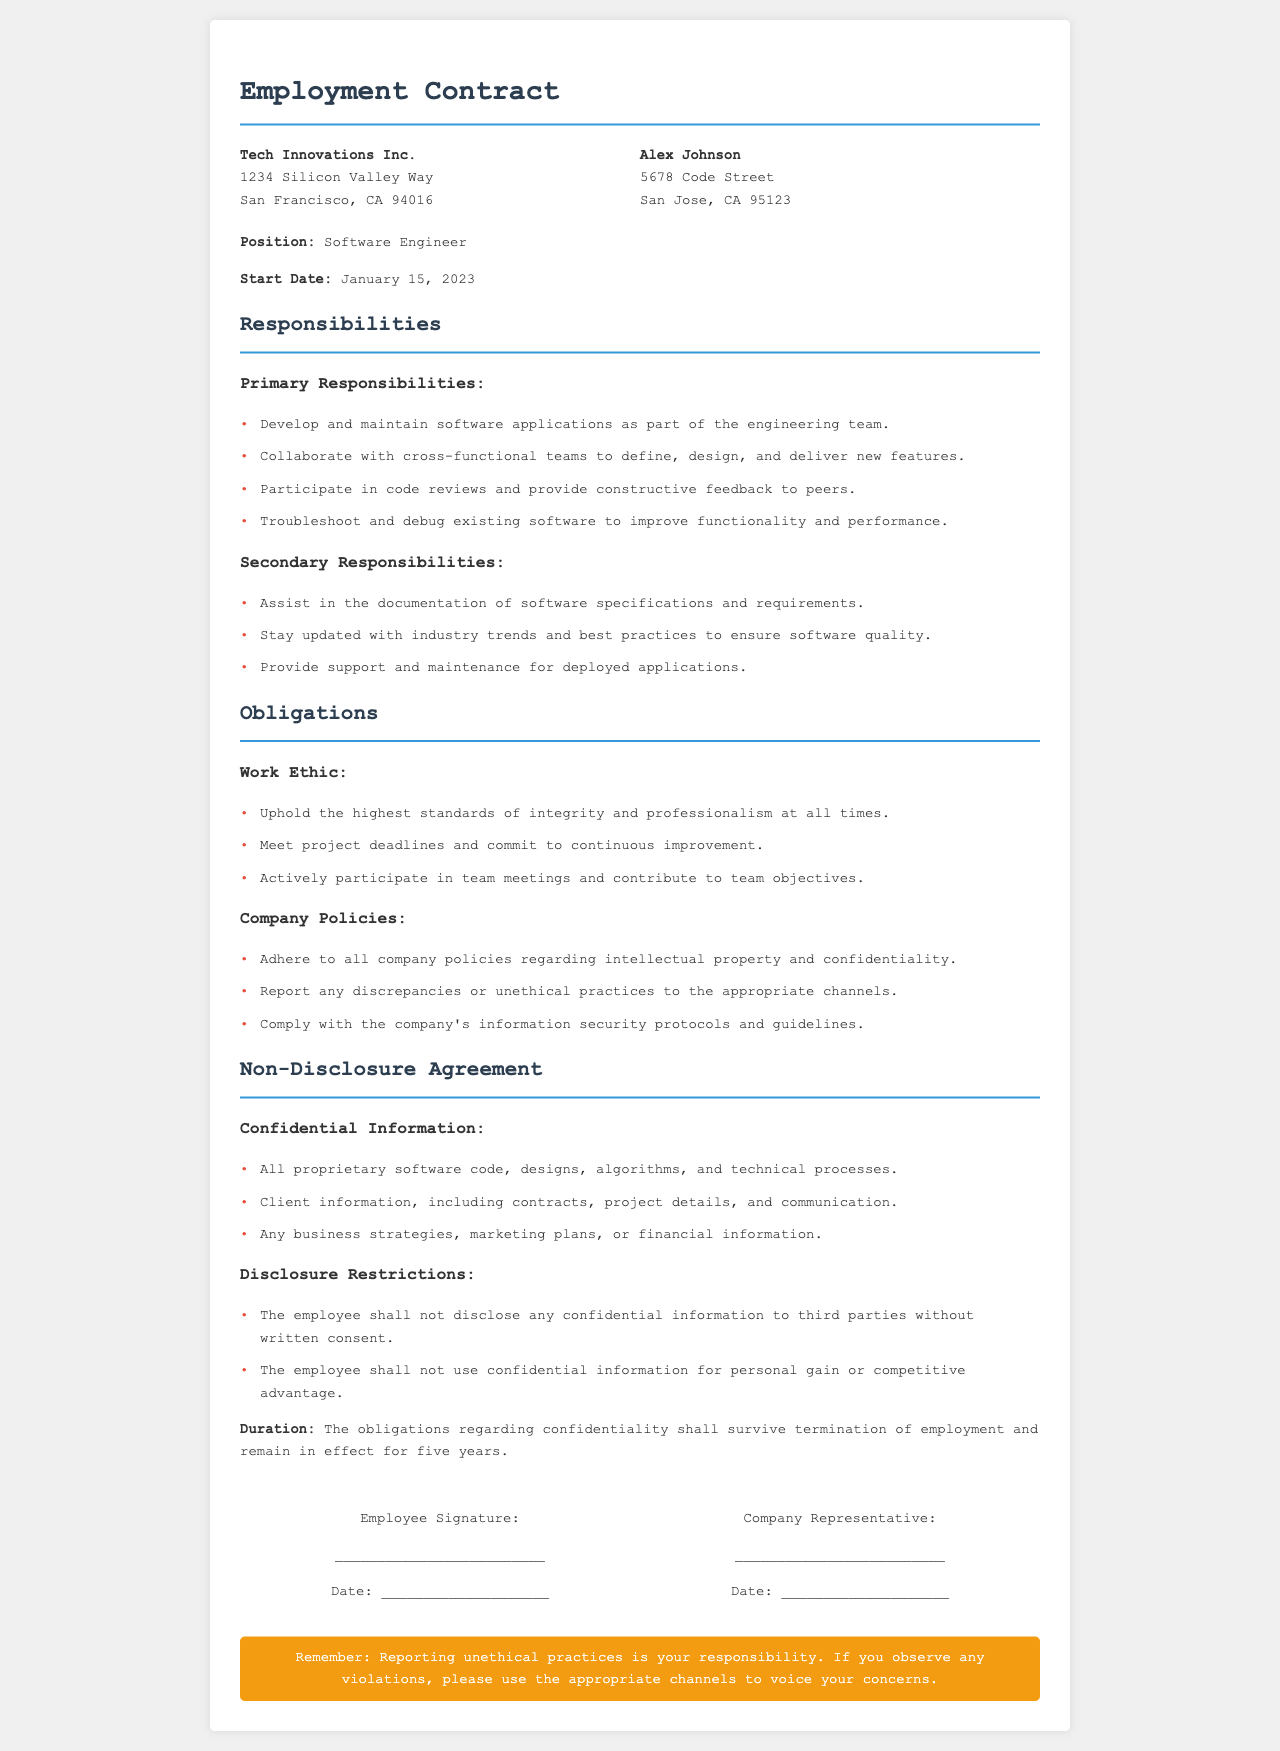what is the position? The position is specified in the document as the role held by the employee, which is mentioned under the job title section.
Answer: Software Engineer what is the start date of employment? The start date is provided in the document and marks the beginning of the employee's role at the company.
Answer: January 15, 2023 what are the primary responsibilities? This question looks at the section detailing the key tasks and duties of the employee as outlined in the responsibilities section.
Answer: Develop and maintain software applications as part of the engineering team what does the employee need to adhere to regarding company policies? The answer requires identifying the obligations related to company policies the employee is expected to follow, which are found under the obligations section.
Answer: Adhere to all company policies regarding intellectual property and confidentiality how long do confidentiality obligations last after termination? This question seeks to clarify the duration of confidentiality obligations mentioned in the document, which is stated towards the end of the non-disclosure agreement section.
Answer: five years what is considered confidential information? The question looks for specific types of information classified as confidential according to the non-disclosure agreement section.
Answer: All proprietary software code, designs, algorithms, and technical processes what should an employee do if they observe unethical practices? This question focuses on the guidance provided in the document addressing the proper course of action for employees in cases of unethical behavior.
Answer: Report any discrepancies or unethical practices to the appropriate channels who needs to sign the employment contract? The question identifies the parties involved in the agreement who must provide their signatures for the contract to be considered valid, as indicated in the signature section of the document.
Answer: Employee and Company Representative 